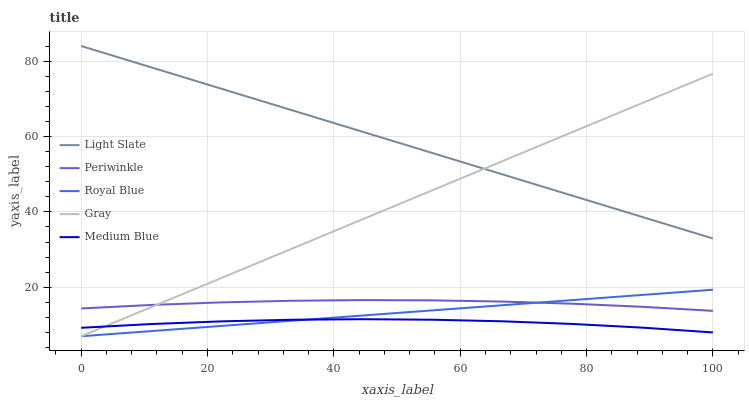Does Medium Blue have the minimum area under the curve?
Answer yes or no. Yes. Does Light Slate have the maximum area under the curve?
Answer yes or no. Yes. Does Royal Blue have the minimum area under the curve?
Answer yes or no. No. Does Royal Blue have the maximum area under the curve?
Answer yes or no. No. Is Royal Blue the smoothest?
Answer yes or no. Yes. Is Medium Blue the roughest?
Answer yes or no. Yes. Is Periwinkle the smoothest?
Answer yes or no. No. Is Periwinkle the roughest?
Answer yes or no. No. Does Royal Blue have the lowest value?
Answer yes or no. Yes. Does Periwinkle have the lowest value?
Answer yes or no. No. Does Light Slate have the highest value?
Answer yes or no. Yes. Does Royal Blue have the highest value?
Answer yes or no. No. Is Medium Blue less than Periwinkle?
Answer yes or no. Yes. Is Light Slate greater than Periwinkle?
Answer yes or no. Yes. Does Gray intersect Light Slate?
Answer yes or no. Yes. Is Gray less than Light Slate?
Answer yes or no. No. Is Gray greater than Light Slate?
Answer yes or no. No. Does Medium Blue intersect Periwinkle?
Answer yes or no. No. 